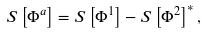<formula> <loc_0><loc_0><loc_500><loc_500>S \left [ \Phi ^ { a } \right ] = S \left [ \Phi ^ { 1 } \right ] - S \left [ \Phi ^ { 2 } \right ] ^ { * } ,</formula> 